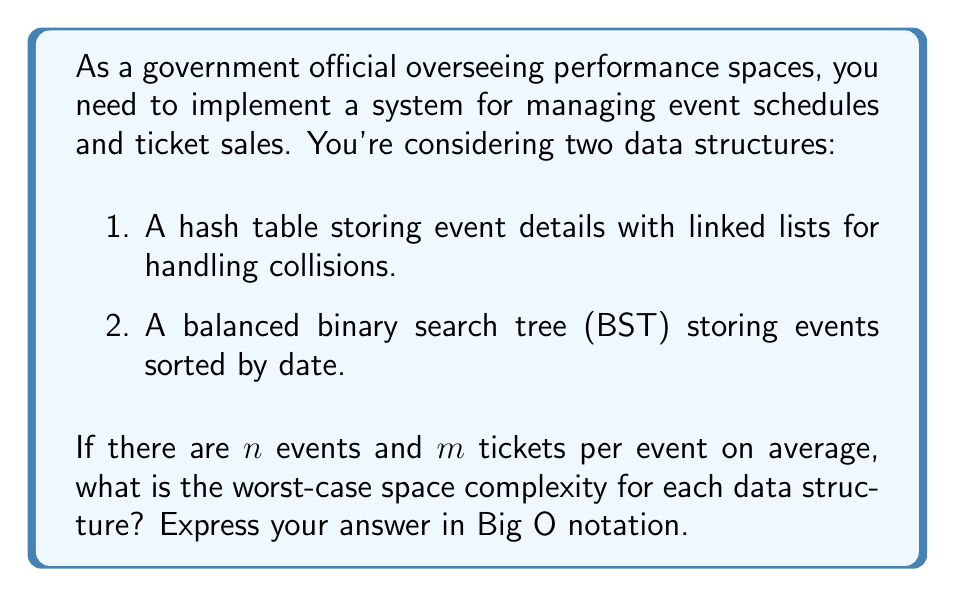Help me with this question. Let's analyze the space complexity of both data structures:

1. Hash table with linked lists:
   - Each event is stored as a key-value pair in the hash table.
   - The hash table itself requires $O(n)$ space for $n$ events.
   - In the worst case (all events hash to the same bucket), we have a single linked list of length $n$.
   - Each node in the linked list stores event details and a pointer to the next node.
   - For each event, we store $m$ tickets on average.
   
   Space complexity: $O(n)$ (hash table) + $O(n)$ (linked list) + $O(nm)$ (tickets) = $O(n + nm)$ = $O(nm)$

2. Balanced Binary Search Tree (BST):
   - The BST stores $n$ nodes, one for each event.
   - Each node contains event details, left and right child pointers, and potentially a parent pointer and balance information.
   - For each event, we store $m$ tickets on average.
   
   Space complexity: $O(n)$ (BST structure) + $O(nm)$ (tickets) = $O(n + nm)$ = $O(nm)$

Both data structures have the same worst-case space complexity of $O(nm)$. The dominant factor is the storage of tickets, which requires $O(nm)$ space in both cases. The difference in the underlying structures (hash table with linked lists vs. BST) becomes insignificant as $n$ and $m$ grow large.
Answer: The worst-case space complexity for both data structures is $O(nm)$. 